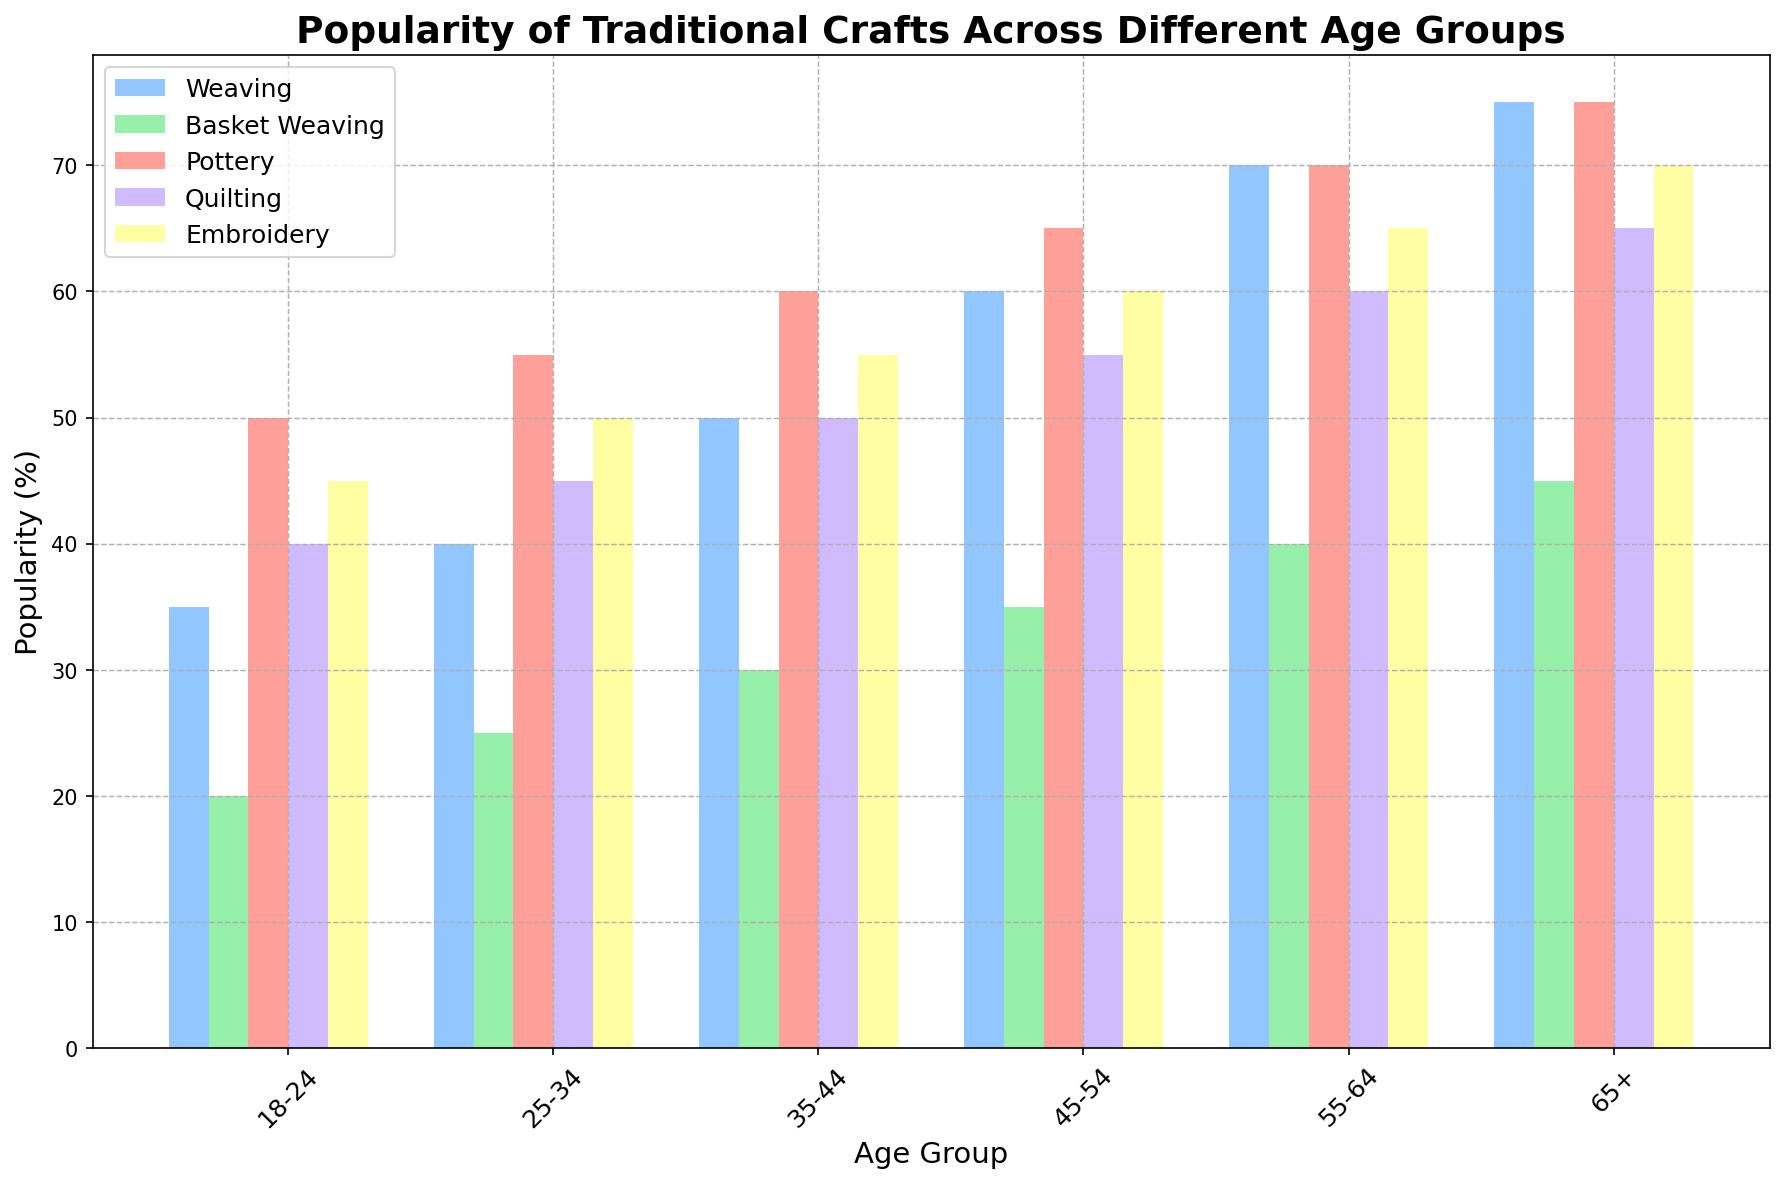What's the most popular traditional craft among the 18-24 age group? The bar representing "Pottery" is the tallest among the crafts for the 18-24 age group.
Answer: Pottery Which age group shows the highest interest in basket weaving? By comparing the heights of the bars for basket weaving across all age groups, the 65+ age group has the tallest bar.
Answer: 65+ How does the popularity of weaving change from the 25-34 age group to the 55-64 age group? The height of the bar for weaving increases from 40% in the 25-34 age group to 70% in the 55-64 age group.
Answer: Increases Between the 18-24 and 45-54 age groups, which has a higher average popularity across all crafts? (Sum of popularity percentages for 18-24: 35 + 20 + 50 + 40 + 45 = 190) vs. (Sum for 45-54: 60 + 35 + 65 + 55 + 60 = 275). Then, calculate averages: 190/5 = 38 for 18-24 and 275/5 = 55 for 45-54.
Answer: 45-54 Is the popularity of quilting for the 35-44 age group greater or less than the popularity of embroidery for the 18-24 age group? Compare the height of the bar for quilting in the 35-44 age group (50%) with the height of the bar for embroidery in the 18-24 age group (45%).
Answer: Greater Which craft shows an increasing trend in popularity across all age groups? By analyzing the bars for each craft from left to right, weaving consistently increases in popularity.
Answer: Weaving Calculate the total percentage of popularity for basket weaving across all age groups. Add percentages for basket weaving across all age groups: 20 + 25 + 30 + 35 + 40 + 45 = 195.
Answer: 195 Does the 65+ age group have double the popularity for basket weaving compared to the 18-24 age group? The percentage for basket weaving in the 65+ age group is 45% and in the 18-24 age group is 20%. 20% doubled is 40%, which is less than 45%.
Answer: Yes What's the difference in popularity of pottery between the oldest (65+) and youngest (18-24) age groups? Subtract the pottery percentage for 18-24 (50%) from that for 65+ (75%).
Answer: 25 